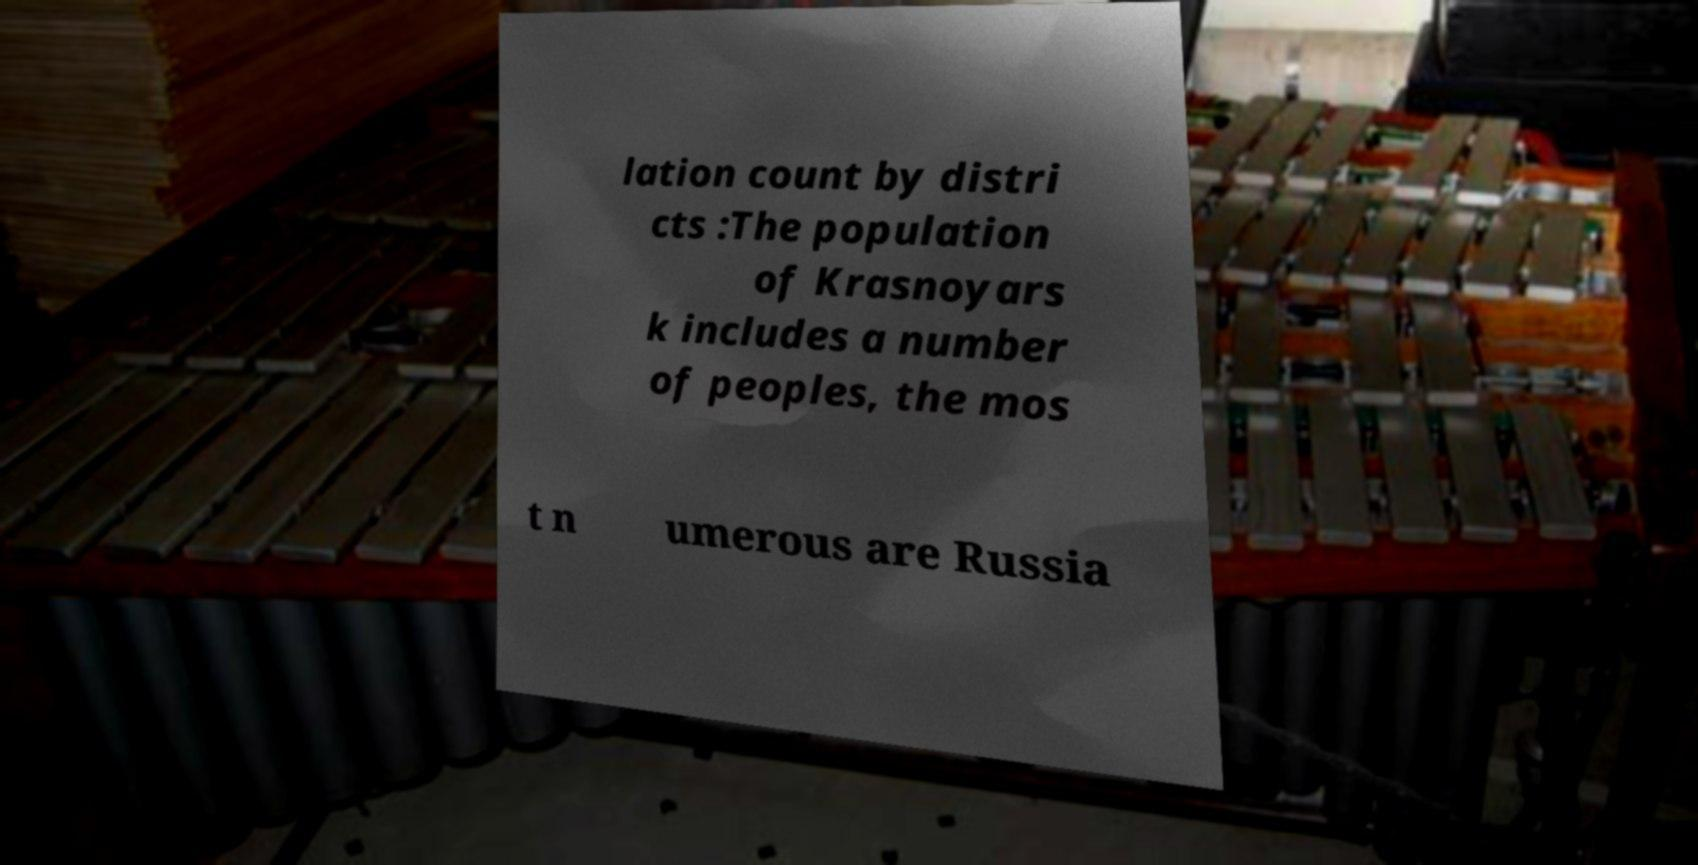Can you accurately transcribe the text from the provided image for me? lation count by distri cts :The population of Krasnoyars k includes a number of peoples, the mos t n umerous are Russia 